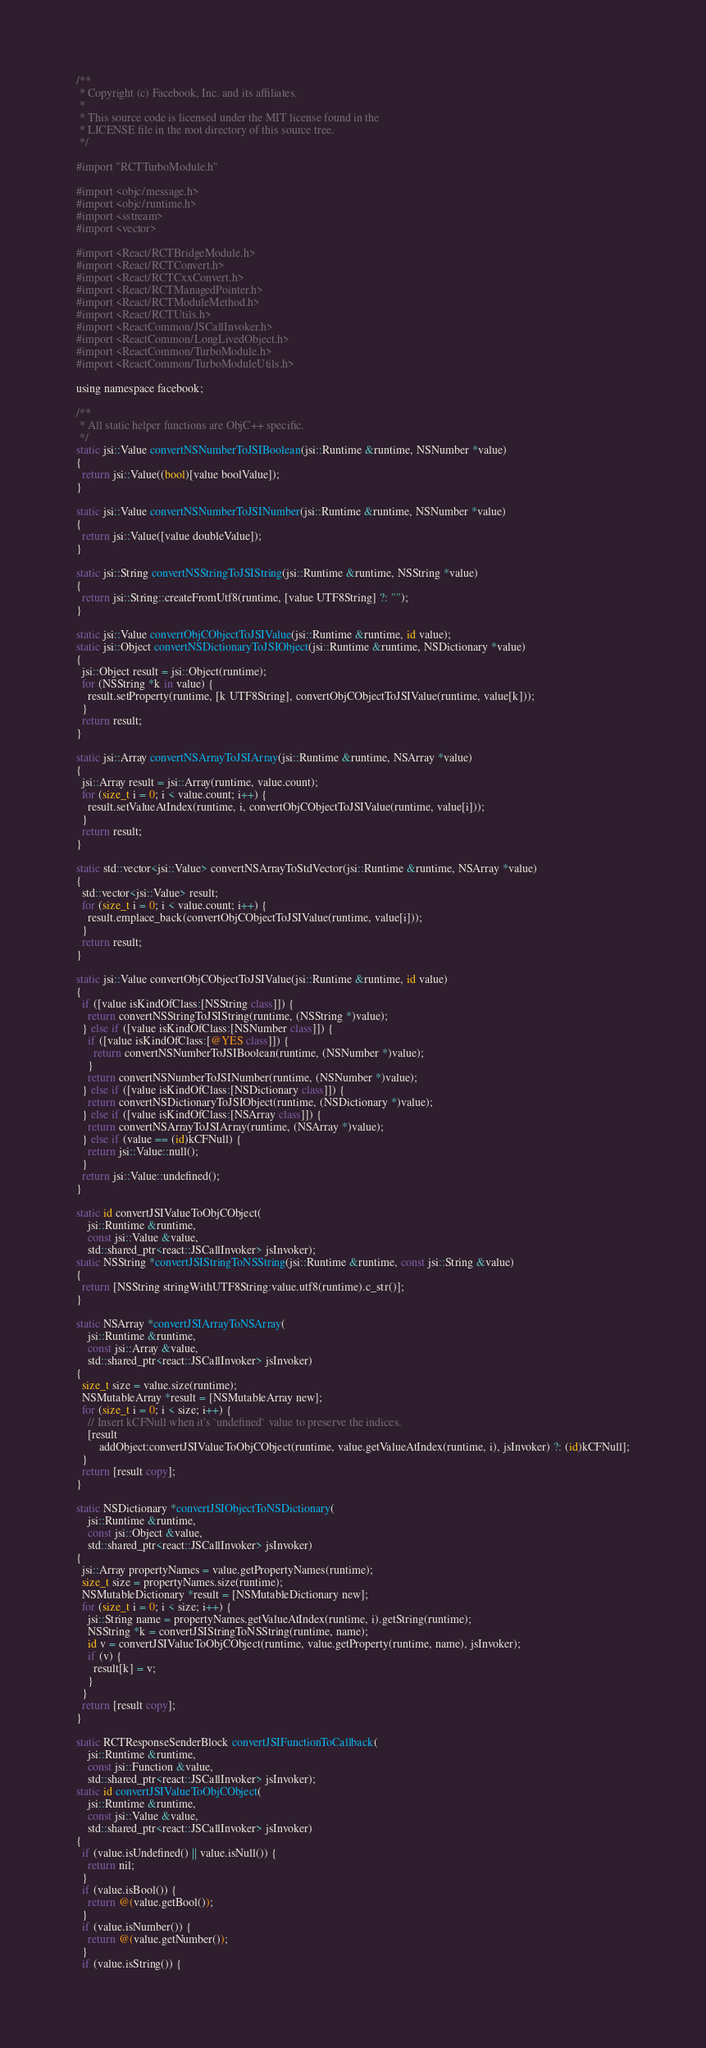Convert code to text. <code><loc_0><loc_0><loc_500><loc_500><_ObjectiveC_>/**
 * Copyright (c) Facebook, Inc. and its affiliates.
 *
 * This source code is licensed under the MIT license found in the
 * LICENSE file in the root directory of this source tree.
 */

#import "RCTTurboModule.h"

#import <objc/message.h>
#import <objc/runtime.h>
#import <sstream>
#import <vector>

#import <React/RCTBridgeModule.h>
#import <React/RCTConvert.h>
#import <React/RCTCxxConvert.h>
#import <React/RCTManagedPointer.h>
#import <React/RCTModuleMethod.h>
#import <React/RCTUtils.h>
#import <ReactCommon/JSCallInvoker.h>
#import <ReactCommon/LongLivedObject.h>
#import <ReactCommon/TurboModule.h>
#import <ReactCommon/TurboModuleUtils.h>

using namespace facebook;

/**
 * All static helper functions are ObjC++ specific.
 */
static jsi::Value convertNSNumberToJSIBoolean(jsi::Runtime &runtime, NSNumber *value)
{
  return jsi::Value((bool)[value boolValue]);
}

static jsi::Value convertNSNumberToJSINumber(jsi::Runtime &runtime, NSNumber *value)
{
  return jsi::Value([value doubleValue]);
}

static jsi::String convertNSStringToJSIString(jsi::Runtime &runtime, NSString *value)
{
  return jsi::String::createFromUtf8(runtime, [value UTF8String] ?: "");
}

static jsi::Value convertObjCObjectToJSIValue(jsi::Runtime &runtime, id value);
static jsi::Object convertNSDictionaryToJSIObject(jsi::Runtime &runtime, NSDictionary *value)
{
  jsi::Object result = jsi::Object(runtime);
  for (NSString *k in value) {
    result.setProperty(runtime, [k UTF8String], convertObjCObjectToJSIValue(runtime, value[k]));
  }
  return result;
}

static jsi::Array convertNSArrayToJSIArray(jsi::Runtime &runtime, NSArray *value)
{
  jsi::Array result = jsi::Array(runtime, value.count);
  for (size_t i = 0; i < value.count; i++) {
    result.setValueAtIndex(runtime, i, convertObjCObjectToJSIValue(runtime, value[i]));
  }
  return result;
}

static std::vector<jsi::Value> convertNSArrayToStdVector(jsi::Runtime &runtime, NSArray *value)
{
  std::vector<jsi::Value> result;
  for (size_t i = 0; i < value.count; i++) {
    result.emplace_back(convertObjCObjectToJSIValue(runtime, value[i]));
  }
  return result;
}

static jsi::Value convertObjCObjectToJSIValue(jsi::Runtime &runtime, id value)
{
  if ([value isKindOfClass:[NSString class]]) {
    return convertNSStringToJSIString(runtime, (NSString *)value);
  } else if ([value isKindOfClass:[NSNumber class]]) {
    if ([value isKindOfClass:[@YES class]]) {
      return convertNSNumberToJSIBoolean(runtime, (NSNumber *)value);
    }
    return convertNSNumberToJSINumber(runtime, (NSNumber *)value);
  } else if ([value isKindOfClass:[NSDictionary class]]) {
    return convertNSDictionaryToJSIObject(runtime, (NSDictionary *)value);
  } else if ([value isKindOfClass:[NSArray class]]) {
    return convertNSArrayToJSIArray(runtime, (NSArray *)value);
  } else if (value == (id)kCFNull) {
    return jsi::Value::null();
  }
  return jsi::Value::undefined();
}

static id convertJSIValueToObjCObject(
    jsi::Runtime &runtime,
    const jsi::Value &value,
    std::shared_ptr<react::JSCallInvoker> jsInvoker);
static NSString *convertJSIStringToNSString(jsi::Runtime &runtime, const jsi::String &value)
{
  return [NSString stringWithUTF8String:value.utf8(runtime).c_str()];
}

static NSArray *convertJSIArrayToNSArray(
    jsi::Runtime &runtime,
    const jsi::Array &value,
    std::shared_ptr<react::JSCallInvoker> jsInvoker)
{
  size_t size = value.size(runtime);
  NSMutableArray *result = [NSMutableArray new];
  for (size_t i = 0; i < size; i++) {
    // Insert kCFNull when it's `undefined` value to preserve the indices.
    [result
        addObject:convertJSIValueToObjCObject(runtime, value.getValueAtIndex(runtime, i), jsInvoker) ?: (id)kCFNull];
  }
  return [result copy];
}

static NSDictionary *convertJSIObjectToNSDictionary(
    jsi::Runtime &runtime,
    const jsi::Object &value,
    std::shared_ptr<react::JSCallInvoker> jsInvoker)
{
  jsi::Array propertyNames = value.getPropertyNames(runtime);
  size_t size = propertyNames.size(runtime);
  NSMutableDictionary *result = [NSMutableDictionary new];
  for (size_t i = 0; i < size; i++) {
    jsi::String name = propertyNames.getValueAtIndex(runtime, i).getString(runtime);
    NSString *k = convertJSIStringToNSString(runtime, name);
    id v = convertJSIValueToObjCObject(runtime, value.getProperty(runtime, name), jsInvoker);
    if (v) {
      result[k] = v;
    }
  }
  return [result copy];
}

static RCTResponseSenderBlock convertJSIFunctionToCallback(
    jsi::Runtime &runtime,
    const jsi::Function &value,
    std::shared_ptr<react::JSCallInvoker> jsInvoker);
static id convertJSIValueToObjCObject(
    jsi::Runtime &runtime,
    const jsi::Value &value,
    std::shared_ptr<react::JSCallInvoker> jsInvoker)
{
  if (value.isUndefined() || value.isNull()) {
    return nil;
  }
  if (value.isBool()) {
    return @(value.getBool());
  }
  if (value.isNumber()) {
    return @(value.getNumber());
  }
  if (value.isString()) {</code> 